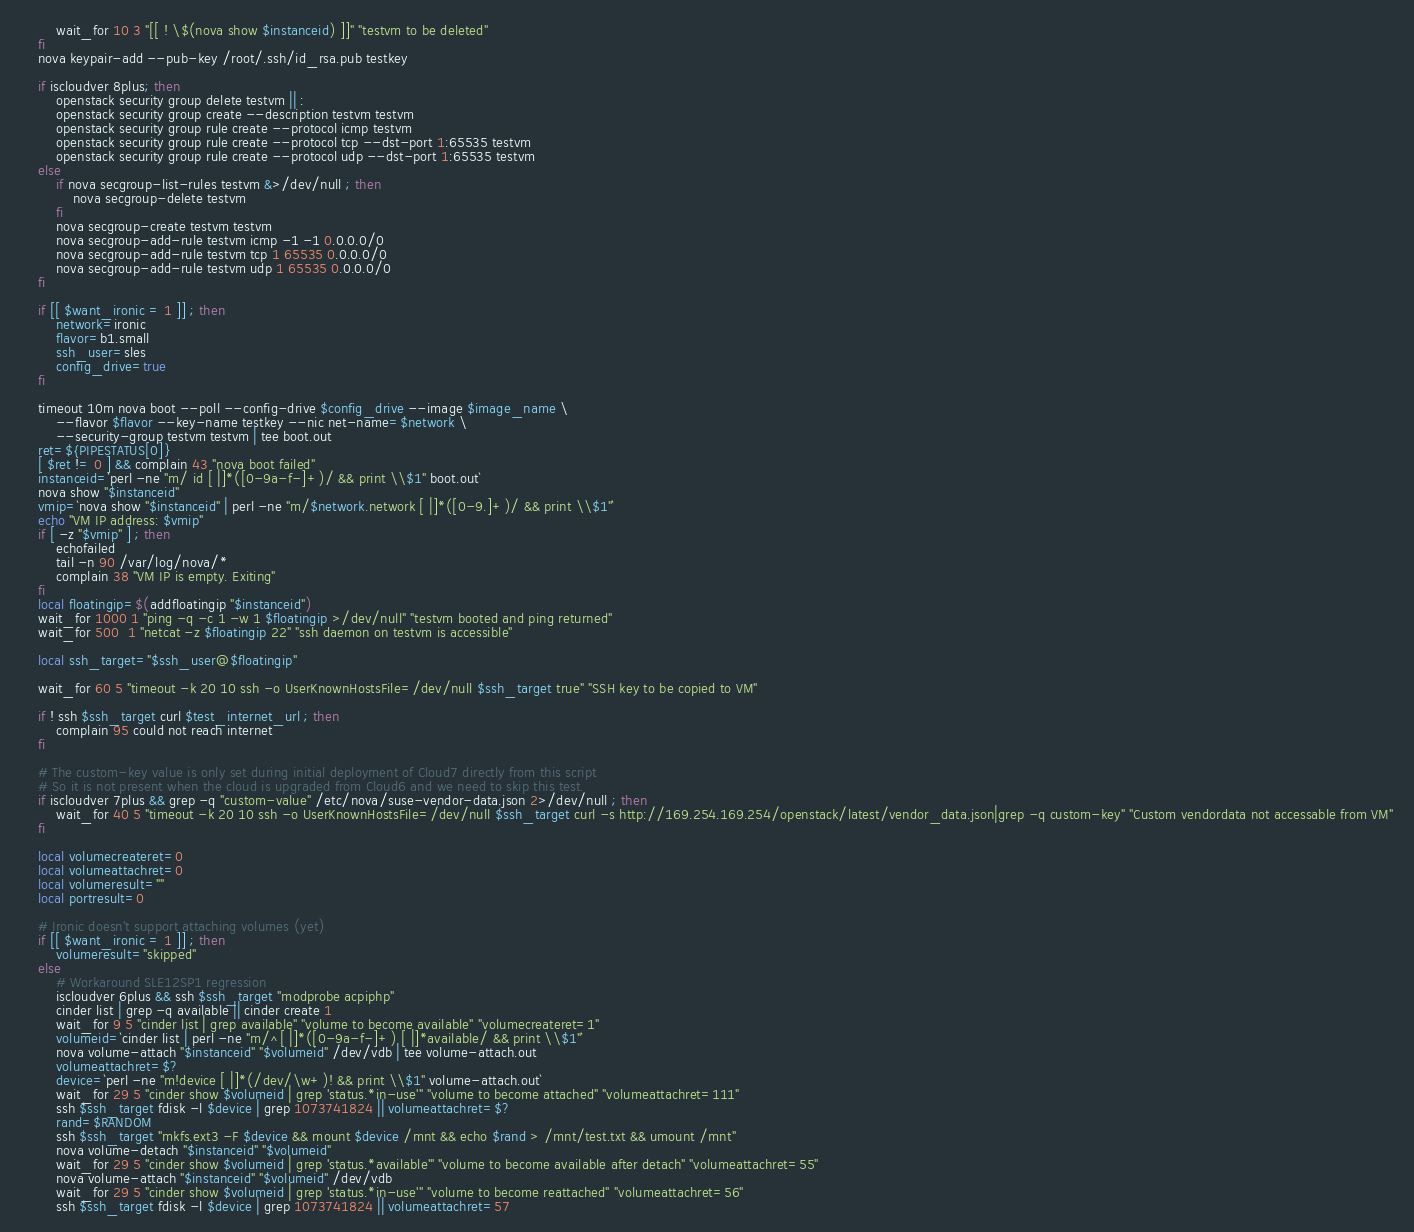Convert code to text. <code><loc_0><loc_0><loc_500><loc_500><_Bash_>        wait_for 10 3 "[[ ! \$(nova show $instanceid) ]]" "testvm to be deleted"
    fi
    nova keypair-add --pub-key /root/.ssh/id_rsa.pub testkey

    if iscloudver 8plus; then
        openstack security group delete testvm || :
        openstack security group create --description testvm testvm
        openstack security group rule create --protocol icmp testvm
        openstack security group rule create --protocol tcp --dst-port 1:65535 testvm
        openstack security group rule create --protocol udp --dst-port 1:65535 testvm
    else
        if nova secgroup-list-rules testvm &>/dev/null ; then
            nova secgroup-delete testvm
        fi
        nova secgroup-create testvm testvm
        nova secgroup-add-rule testvm icmp -1 -1 0.0.0.0/0
        nova secgroup-add-rule testvm tcp 1 65535 0.0.0.0/0
        nova secgroup-add-rule testvm udp 1 65535 0.0.0.0/0
    fi

    if [[ $want_ironic = 1 ]] ; then
        network=ironic
        flavor=b1.small
        ssh_user=sles
        config_drive=true
    fi

    timeout 10m nova boot --poll --config-drive $config_drive --image $image_name \
        --flavor $flavor --key-name testkey --nic net-name=$network \
        --security-group testvm testvm | tee boot.out
    ret=${PIPESTATUS[0]}
    [ $ret != 0 ] && complain 43 "nova boot failed"
    instanceid=`perl -ne "m/ id [ |]*([0-9a-f-]+)/ && print \\$1" boot.out`
    nova show "$instanceid"
    vmip=`nova show "$instanceid" | perl -ne "m/$network.network [ |]*([0-9.]+)/ && print \\$1"`
    echo "VM IP address: $vmip"
    if [ -z "$vmip" ] ; then
        echofailed
        tail -n 90 /var/log/nova/*
        complain 38 "VM IP is empty. Exiting"
    fi
    local floatingip=$(addfloatingip "$instanceid")
    wait_for 1000 1 "ping -q -c 1 -w 1 $floatingip >/dev/null" "testvm booted and ping returned"
    wait_for 500  1 "netcat -z $floatingip 22" "ssh daemon on testvm is accessible"

    local ssh_target="$ssh_user@$floatingip"

    wait_for 60 5 "timeout -k 20 10 ssh -o UserKnownHostsFile=/dev/null $ssh_target true" "SSH key to be copied to VM"

    if ! ssh $ssh_target curl $test_internet_url ; then
        complain 95 could not reach internet
    fi

    # The custom-key value is only set during initial deployment of Cloud7 directly from this script
    # So it is not present when the cloud is upgraded from Cloud6 and we need to skip this test.
    if iscloudver 7plus && grep -q "custom-value" /etc/nova/suse-vendor-data.json 2>/dev/null ; then
        wait_for 40 5 "timeout -k 20 10 ssh -o UserKnownHostsFile=/dev/null $ssh_target curl -s http://169.254.169.254/openstack/latest/vendor_data.json|grep -q custom-key" "Custom vendordata not accessable from VM"
    fi

    local volumecreateret=0
    local volumeattachret=0
    local volumeresult=""
    local portresult=0

    # Ironic doesn't support attaching volumes (yet)
    if [[ $want_ironic = 1 ]] ; then
        volumeresult="skipped"
    else
        # Workaround SLE12SP1 regression
        iscloudver 6plus && ssh $ssh_target "modprobe acpiphp"
        cinder list | grep -q available || cinder create 1
        wait_for 9 5 "cinder list | grep available" "volume to become available" "volumecreateret=1"
        volumeid=`cinder list | perl -ne "m/^[ |]*([0-9a-f-]+) [ |]*available/ && print \\$1"`
        nova volume-attach "$instanceid" "$volumeid" /dev/vdb | tee volume-attach.out
        volumeattachret=$?
        device=`perl -ne "m!device [ |]*(/dev/\w+)! && print \\$1" volume-attach.out`
        wait_for 29 5 "cinder show $volumeid | grep 'status.*in-use'" "volume to become attached" "volumeattachret=111"
        ssh $ssh_target fdisk -l $device | grep 1073741824 || volumeattachret=$?
        rand=$RANDOM
        ssh $ssh_target "mkfs.ext3 -F $device && mount $device /mnt && echo $rand > /mnt/test.txt && umount /mnt"
        nova volume-detach "$instanceid" "$volumeid"
        wait_for 29 5 "cinder show $volumeid | grep 'status.*available'" "volume to become available after detach" "volumeattachret=55"
        nova volume-attach "$instanceid" "$volumeid" /dev/vdb
        wait_for 29 5 "cinder show $volumeid | grep 'status.*in-use'" "volume to become reattached" "volumeattachret=56"
        ssh $ssh_target fdisk -l $device | grep 1073741824 || volumeattachret=57</code> 